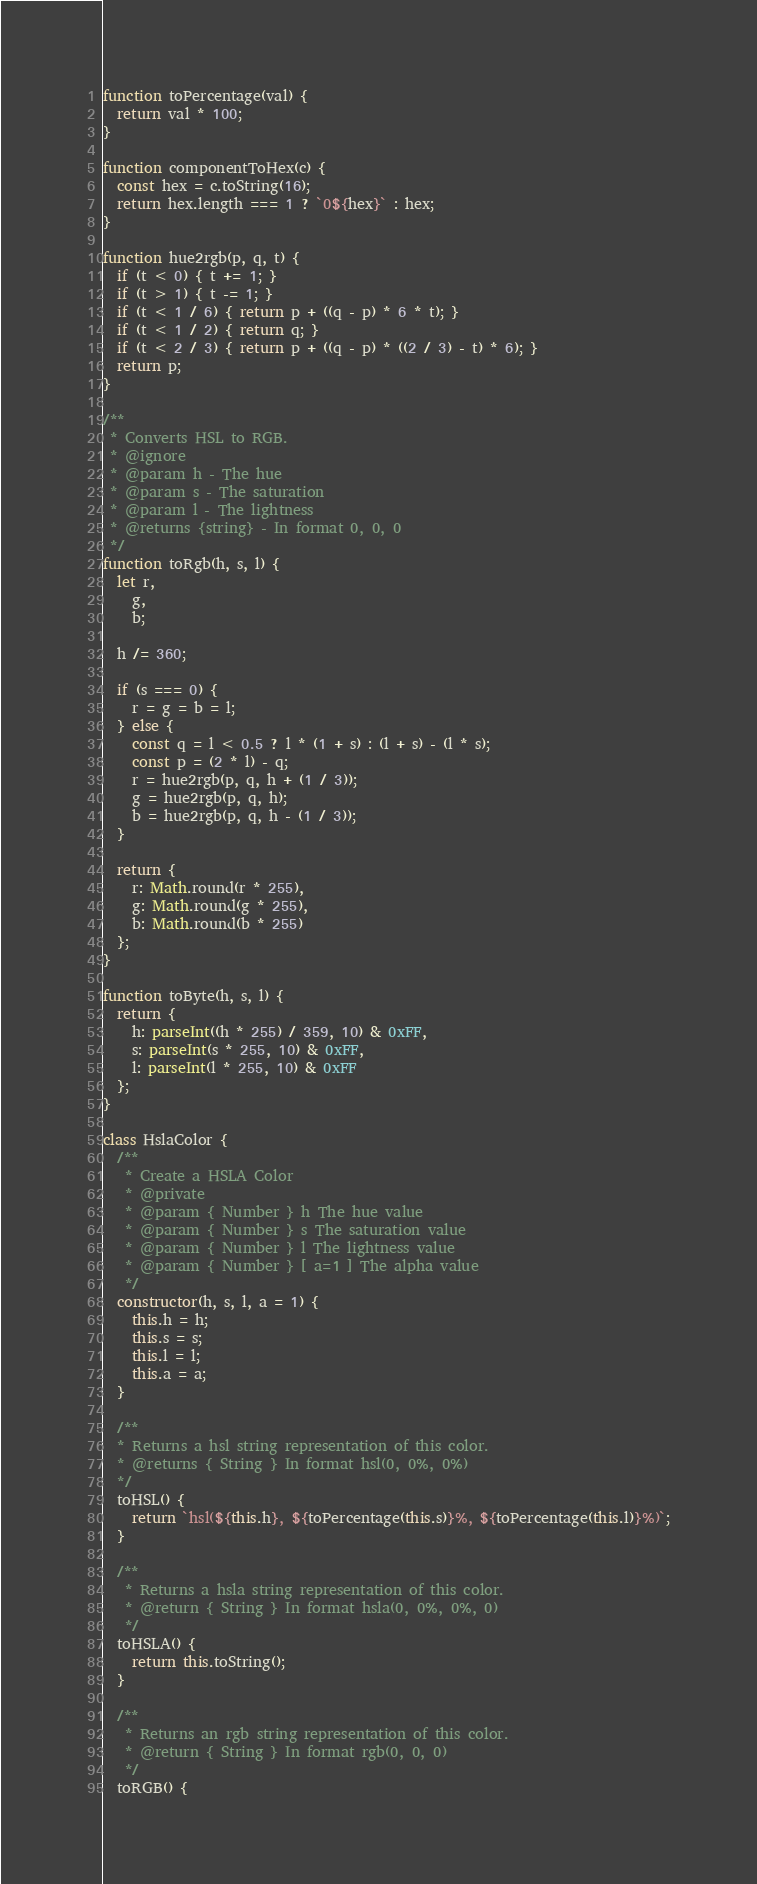Convert code to text. <code><loc_0><loc_0><loc_500><loc_500><_JavaScript_>function toPercentage(val) {
  return val * 100;
}

function componentToHex(c) {
  const hex = c.toString(16);
  return hex.length === 1 ? `0${hex}` : hex;
}

function hue2rgb(p, q, t) {
  if (t < 0) { t += 1; }
  if (t > 1) { t -= 1; }
  if (t < 1 / 6) { return p + ((q - p) * 6 * t); }
  if (t < 1 / 2) { return q; }
  if (t < 2 / 3) { return p + ((q - p) * ((2 / 3) - t) * 6); }
  return p;
}

/**
 * Converts HSL to RGB.
 * @ignore
 * @param h - The hue
 * @param s - The saturation
 * @param l - The lightness
 * @returns {string} - In format 0, 0, 0
 */
function toRgb(h, s, l) {
  let r,
    g,
    b;

  h /= 360;

  if (s === 0) {
    r = g = b = l;
  } else {
    const q = l < 0.5 ? l * (1 + s) : (l + s) - (l * s);
    const p = (2 * l) - q;
    r = hue2rgb(p, q, h + (1 / 3));
    g = hue2rgb(p, q, h);
    b = hue2rgb(p, q, h - (1 / 3));
  }

  return {
    r: Math.round(r * 255),
    g: Math.round(g * 255),
    b: Math.round(b * 255)
  };
}

function toByte(h, s, l) {
  return {
    h: parseInt((h * 255) / 359, 10) & 0xFF,
    s: parseInt(s * 255, 10) & 0xFF,
    l: parseInt(l * 255, 10) & 0xFF
  };
}

class HslaColor {
  /**
   * Create a HSLA Color
   * @private
   * @param { Number } h The hue value
   * @param { Number } s The saturation value
   * @param { Number } l The lightness value
   * @param { Number } [ a=1 ] The alpha value
   */
  constructor(h, s, l, a = 1) {
    this.h = h;
    this.s = s;
    this.l = l;
    this.a = a;
  }

  /**
  * Returns a hsl string representation of this color.
  * @returns { String } In format hsl(0, 0%, 0%)
  */
  toHSL() {
    return `hsl(${this.h}, ${toPercentage(this.s)}%, ${toPercentage(this.l)}%)`;
  }

  /**
   * Returns a hsla string representation of this color.
   * @return { String } In format hsla(0, 0%, 0%, 0)
   */
  toHSLA() {
    return this.toString();
  }

  /**
   * Returns an rgb string representation of this color.
   * @return { String } In format rgb(0, 0, 0)
   */
  toRGB() {</code> 